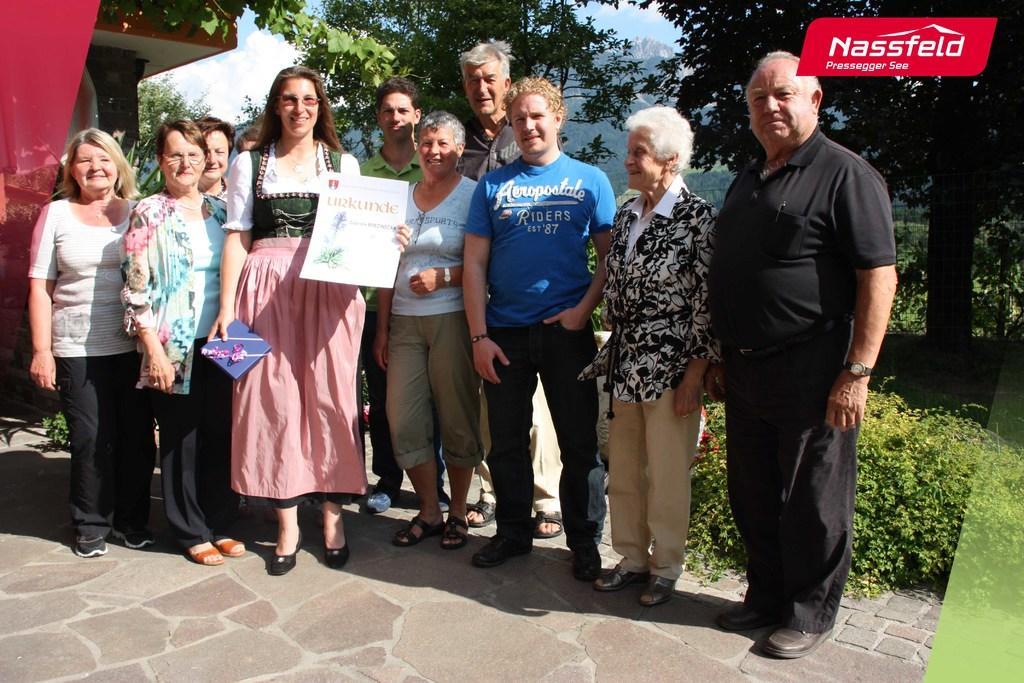Can you describe this image briefly? In the middle of this image few people are standing, smiling and giving pose for the picture. The woman who is in the middle is holding a gift and a paper in the hands. On the left side there is a building. In the background there are many plants and trees. At the top of the image I can see the sky. In the top right-hand corner there is some text. 